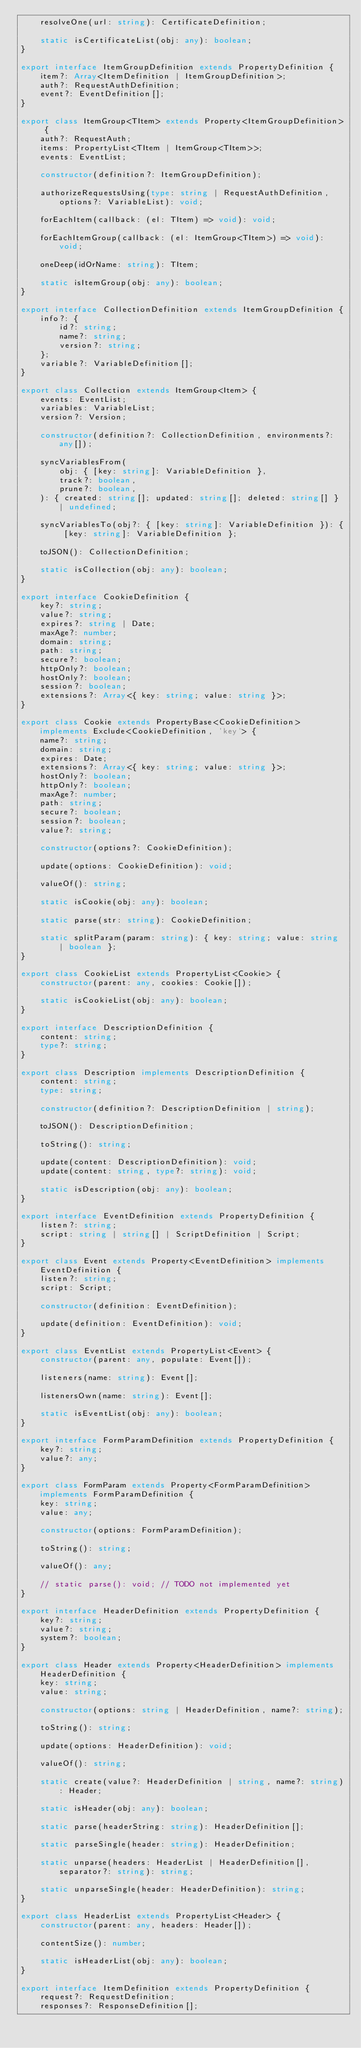<code> <loc_0><loc_0><loc_500><loc_500><_TypeScript_>    resolveOne(url: string): CertificateDefinition;

    static isCertificateList(obj: any): boolean;
}

export interface ItemGroupDefinition extends PropertyDefinition {
    item?: Array<ItemDefinition | ItemGroupDefinition>;
    auth?: RequestAuthDefinition;
    event?: EventDefinition[];
}

export class ItemGroup<TItem> extends Property<ItemGroupDefinition> {
    auth?: RequestAuth;
    items: PropertyList<TItem | ItemGroup<TItem>>;
    events: EventList;

    constructor(definition?: ItemGroupDefinition);

    authorizeRequestsUsing(type: string | RequestAuthDefinition, options?: VariableList): void;

    forEachItem(callback: (el: TItem) => void): void;

    forEachItemGroup(callback: (el: ItemGroup<TItem>) => void): void;

    oneDeep(idOrName: string): TItem;

    static isItemGroup(obj: any): boolean;
}

export interface CollectionDefinition extends ItemGroupDefinition {
    info?: {
        id?: string;
        name?: string;
        version?: string;
    };
    variable?: VariableDefinition[];
}

export class Collection extends ItemGroup<Item> {
    events: EventList;
    variables: VariableList;
    version?: Version;

    constructor(definition?: CollectionDefinition, environments?: any[]);

    syncVariablesFrom(
        obj: { [key: string]: VariableDefinition },
        track?: boolean,
        prune?: boolean,
    ): { created: string[]; updated: string[]; deleted: string[] } | undefined;

    syncVariablesTo(obj?: { [key: string]: VariableDefinition }): { [key: string]: VariableDefinition };

    toJSON(): CollectionDefinition;

    static isCollection(obj: any): boolean;
}

export interface CookieDefinition {
    key?: string;
    value?: string;
    expires?: string | Date;
    maxAge?: number;
    domain: string;
    path: string;
    secure?: boolean;
    httpOnly?: boolean;
    hostOnly?: boolean;
    session?: boolean;
    extensions?: Array<{ key: string; value: string }>;
}

export class Cookie extends PropertyBase<CookieDefinition> implements Exclude<CookieDefinition, 'key'> {
    name?: string;
    domain: string;
    expires: Date;
    extensions?: Array<{ key: string; value: string }>;
    hostOnly?: boolean;
    httpOnly?: boolean;
    maxAge?: number;
    path: string;
    secure?: boolean;
    session?: boolean;
    value?: string;

    constructor(options?: CookieDefinition);

    update(options: CookieDefinition): void;

    valueOf(): string;

    static isCookie(obj: any): boolean;

    static parse(str: string): CookieDefinition;

    static splitParam(param: string): { key: string; value: string | boolean };
}

export class CookieList extends PropertyList<Cookie> {
    constructor(parent: any, cookies: Cookie[]);

    static isCookieList(obj: any): boolean;
}

export interface DescriptionDefinition {
    content: string;
    type?: string;
}

export class Description implements DescriptionDefinition {
    content: string;
    type: string;

    constructor(definition?: DescriptionDefinition | string);

    toJSON(): DescriptionDefinition;

    toString(): string;

    update(content: DescriptionDefinition): void;
    update(content: string, type?: string): void;

    static isDescription(obj: any): boolean;
}

export interface EventDefinition extends PropertyDefinition {
    listen?: string;
    script: string | string[] | ScriptDefinition | Script;
}

export class Event extends Property<EventDefinition> implements EventDefinition {
    listen?: string;
    script: Script;

    constructor(definition: EventDefinition);

    update(definition: EventDefinition): void;
}

export class EventList extends PropertyList<Event> {
    constructor(parent: any, populate: Event[]);

    listeners(name: string): Event[];

    listenersOwn(name: string): Event[];

    static isEventList(obj: any): boolean;
}

export interface FormParamDefinition extends PropertyDefinition {
    key?: string;
    value?: any;
}

export class FormParam extends Property<FormParamDefinition> implements FormParamDefinition {
    key: string;
    value: any;

    constructor(options: FormParamDefinition);

    toString(): string;

    valueOf(): any;

    // static parse(): void; // TODO not implemented yet
}

export interface HeaderDefinition extends PropertyDefinition {
    key?: string;
    value?: string;
    system?: boolean;
}

export class Header extends Property<HeaderDefinition> implements HeaderDefinition {
    key: string;
    value: string;

    constructor(options: string | HeaderDefinition, name?: string);

    toString(): string;

    update(options: HeaderDefinition): void;

    valueOf(): string;

    static create(value?: HeaderDefinition | string, name?: string): Header;

    static isHeader(obj: any): boolean;

    static parse(headerString: string): HeaderDefinition[];

    static parseSingle(header: string): HeaderDefinition;

    static unparse(headers: HeaderList | HeaderDefinition[], separator?: string): string;

    static unparseSingle(header: HeaderDefinition): string;
}

export class HeaderList extends PropertyList<Header> {
    constructor(parent: any, headers: Header[]);

    contentSize(): number;

    static isHeaderList(obj: any): boolean;
}

export interface ItemDefinition extends PropertyDefinition {
    request?: RequestDefinition;
    responses?: ResponseDefinition[];</code> 